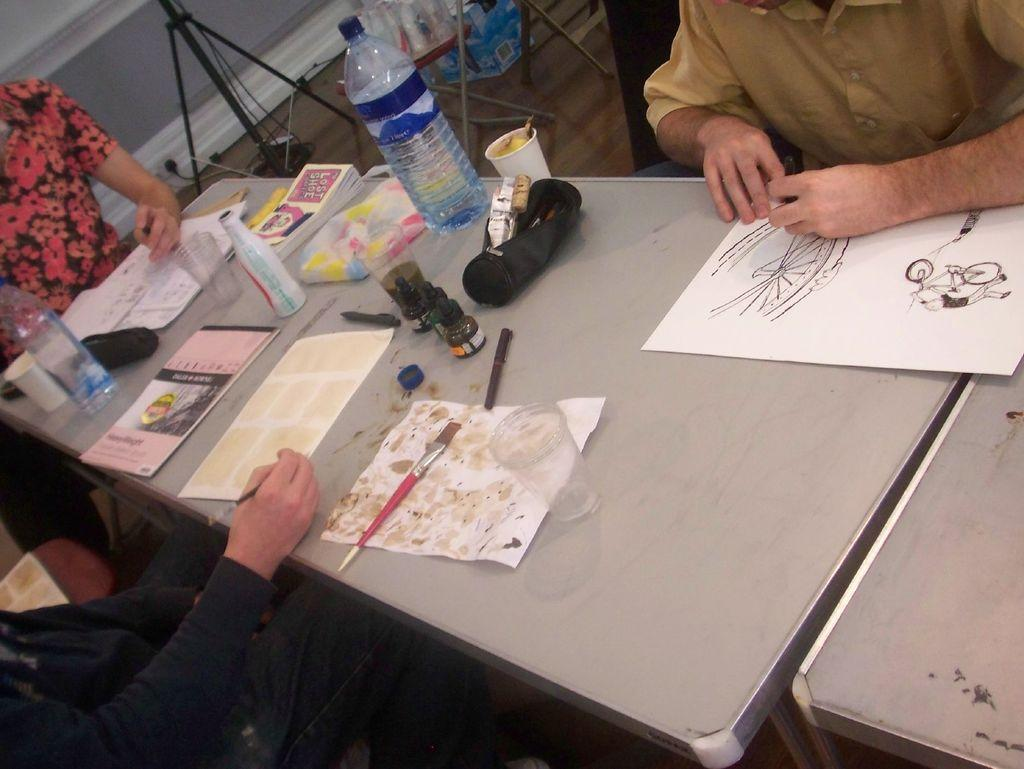How many people are sitting in the image? There are three persons sitting on chairs in the image. What is present on the table in the image? There is a paper, a glass, a paintbrush, a water bottle, and a book on the table in the image. What might the people be using the paper for? It is not clear from the image what the paper is being used for, but it could be for writing, drawing, or reading. What is the purpose of the paintbrush on the table? The purpose of the paintbrush on the table is not clear from the image, but it could be used for painting or drawing. What type of sail can be seen in the image? There is no sail present in the image; it features three persons sitting on chairs and a table with various objects on it. 